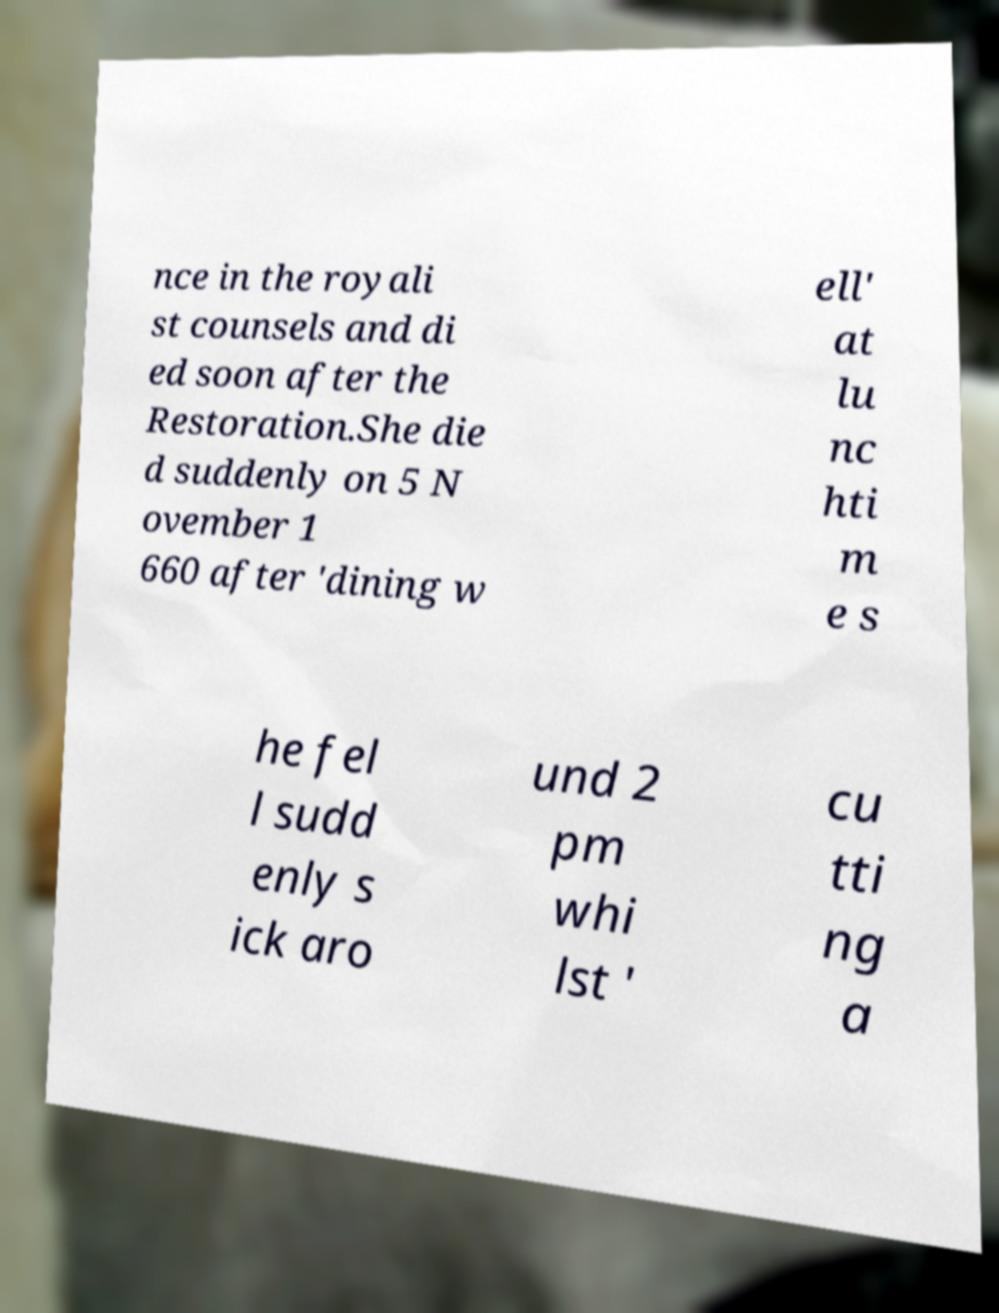There's text embedded in this image that I need extracted. Can you transcribe it verbatim? nce in the royali st counsels and di ed soon after the Restoration.She die d suddenly on 5 N ovember 1 660 after 'dining w ell' at lu nc hti m e s he fel l sudd enly s ick aro und 2 pm whi lst ' cu tti ng a 